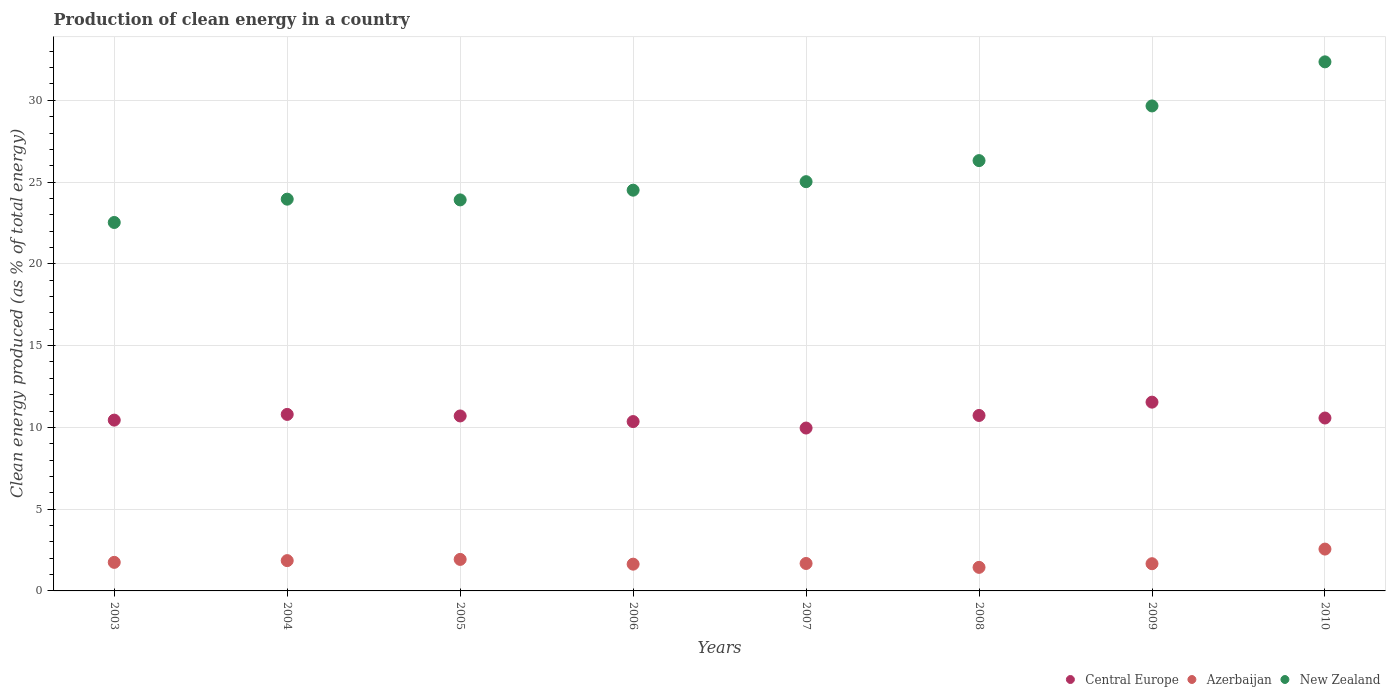How many different coloured dotlines are there?
Give a very brief answer. 3. What is the percentage of clean energy produced in New Zealand in 2007?
Provide a short and direct response. 25.03. Across all years, what is the maximum percentage of clean energy produced in New Zealand?
Keep it short and to the point. 32.35. Across all years, what is the minimum percentage of clean energy produced in Azerbaijan?
Offer a very short reply. 1.44. In which year was the percentage of clean energy produced in New Zealand minimum?
Your answer should be compact. 2003. What is the total percentage of clean energy produced in New Zealand in the graph?
Your answer should be very brief. 208.26. What is the difference between the percentage of clean energy produced in New Zealand in 2006 and that in 2010?
Make the answer very short. -7.85. What is the difference between the percentage of clean energy produced in New Zealand in 2006 and the percentage of clean energy produced in Central Europe in 2007?
Offer a very short reply. 14.55. What is the average percentage of clean energy produced in New Zealand per year?
Give a very brief answer. 26.03. In the year 2004, what is the difference between the percentage of clean energy produced in Azerbaijan and percentage of clean energy produced in Central Europe?
Ensure brevity in your answer.  -8.94. What is the ratio of the percentage of clean energy produced in Central Europe in 2003 to that in 2006?
Ensure brevity in your answer.  1.01. Is the percentage of clean energy produced in New Zealand in 2004 less than that in 2006?
Your answer should be very brief. Yes. Is the difference between the percentage of clean energy produced in Azerbaijan in 2003 and 2007 greater than the difference between the percentage of clean energy produced in Central Europe in 2003 and 2007?
Offer a terse response. No. What is the difference between the highest and the second highest percentage of clean energy produced in New Zealand?
Make the answer very short. 2.7. What is the difference between the highest and the lowest percentage of clean energy produced in Azerbaijan?
Your answer should be compact. 1.12. In how many years, is the percentage of clean energy produced in New Zealand greater than the average percentage of clean energy produced in New Zealand taken over all years?
Offer a terse response. 3. Is the sum of the percentage of clean energy produced in Azerbaijan in 2006 and 2008 greater than the maximum percentage of clean energy produced in New Zealand across all years?
Ensure brevity in your answer.  No. Is the percentage of clean energy produced in New Zealand strictly greater than the percentage of clean energy produced in Azerbaijan over the years?
Your answer should be compact. Yes. How many dotlines are there?
Keep it short and to the point. 3. How many years are there in the graph?
Make the answer very short. 8. What is the difference between two consecutive major ticks on the Y-axis?
Offer a very short reply. 5. Are the values on the major ticks of Y-axis written in scientific E-notation?
Your response must be concise. No. Does the graph contain any zero values?
Provide a short and direct response. No. What is the title of the graph?
Your answer should be very brief. Production of clean energy in a country. Does "North America" appear as one of the legend labels in the graph?
Your answer should be compact. No. What is the label or title of the Y-axis?
Keep it short and to the point. Clean energy produced (as % of total energy). What is the Clean energy produced (as % of total energy) in Central Europe in 2003?
Keep it short and to the point. 10.45. What is the Clean energy produced (as % of total energy) in Azerbaijan in 2003?
Your answer should be compact. 1.75. What is the Clean energy produced (as % of total energy) in New Zealand in 2003?
Give a very brief answer. 22.53. What is the Clean energy produced (as % of total energy) in Central Europe in 2004?
Your answer should be compact. 10.79. What is the Clean energy produced (as % of total energy) in Azerbaijan in 2004?
Offer a terse response. 1.85. What is the Clean energy produced (as % of total energy) in New Zealand in 2004?
Offer a very short reply. 23.96. What is the Clean energy produced (as % of total energy) in Central Europe in 2005?
Provide a short and direct response. 10.7. What is the Clean energy produced (as % of total energy) of Azerbaijan in 2005?
Offer a very short reply. 1.93. What is the Clean energy produced (as % of total energy) of New Zealand in 2005?
Your response must be concise. 23.91. What is the Clean energy produced (as % of total energy) of Central Europe in 2006?
Make the answer very short. 10.36. What is the Clean energy produced (as % of total energy) of Azerbaijan in 2006?
Give a very brief answer. 1.64. What is the Clean energy produced (as % of total energy) of New Zealand in 2006?
Give a very brief answer. 24.51. What is the Clean energy produced (as % of total energy) of Central Europe in 2007?
Your response must be concise. 9.96. What is the Clean energy produced (as % of total energy) in Azerbaijan in 2007?
Provide a short and direct response. 1.68. What is the Clean energy produced (as % of total energy) of New Zealand in 2007?
Keep it short and to the point. 25.03. What is the Clean energy produced (as % of total energy) of Central Europe in 2008?
Offer a very short reply. 10.73. What is the Clean energy produced (as % of total energy) in Azerbaijan in 2008?
Give a very brief answer. 1.44. What is the Clean energy produced (as % of total energy) in New Zealand in 2008?
Your answer should be very brief. 26.31. What is the Clean energy produced (as % of total energy) of Central Europe in 2009?
Give a very brief answer. 11.54. What is the Clean energy produced (as % of total energy) in Azerbaijan in 2009?
Keep it short and to the point. 1.66. What is the Clean energy produced (as % of total energy) of New Zealand in 2009?
Give a very brief answer. 29.66. What is the Clean energy produced (as % of total energy) of Central Europe in 2010?
Keep it short and to the point. 10.57. What is the Clean energy produced (as % of total energy) in Azerbaijan in 2010?
Give a very brief answer. 2.56. What is the Clean energy produced (as % of total energy) in New Zealand in 2010?
Give a very brief answer. 32.35. Across all years, what is the maximum Clean energy produced (as % of total energy) of Central Europe?
Your response must be concise. 11.54. Across all years, what is the maximum Clean energy produced (as % of total energy) of Azerbaijan?
Your response must be concise. 2.56. Across all years, what is the maximum Clean energy produced (as % of total energy) of New Zealand?
Offer a very short reply. 32.35. Across all years, what is the minimum Clean energy produced (as % of total energy) in Central Europe?
Offer a terse response. 9.96. Across all years, what is the minimum Clean energy produced (as % of total energy) in Azerbaijan?
Your response must be concise. 1.44. Across all years, what is the minimum Clean energy produced (as % of total energy) of New Zealand?
Provide a short and direct response. 22.53. What is the total Clean energy produced (as % of total energy) in Central Europe in the graph?
Provide a short and direct response. 85.1. What is the total Clean energy produced (as % of total energy) of Azerbaijan in the graph?
Your answer should be very brief. 14.51. What is the total Clean energy produced (as % of total energy) in New Zealand in the graph?
Your response must be concise. 208.26. What is the difference between the Clean energy produced (as % of total energy) of Central Europe in 2003 and that in 2004?
Keep it short and to the point. -0.35. What is the difference between the Clean energy produced (as % of total energy) in Azerbaijan in 2003 and that in 2004?
Your answer should be compact. -0.11. What is the difference between the Clean energy produced (as % of total energy) in New Zealand in 2003 and that in 2004?
Your answer should be very brief. -1.43. What is the difference between the Clean energy produced (as % of total energy) of Central Europe in 2003 and that in 2005?
Make the answer very short. -0.25. What is the difference between the Clean energy produced (as % of total energy) in Azerbaijan in 2003 and that in 2005?
Make the answer very short. -0.18. What is the difference between the Clean energy produced (as % of total energy) in New Zealand in 2003 and that in 2005?
Offer a very short reply. -1.38. What is the difference between the Clean energy produced (as % of total energy) in Central Europe in 2003 and that in 2006?
Your response must be concise. 0.09. What is the difference between the Clean energy produced (as % of total energy) in Azerbaijan in 2003 and that in 2006?
Give a very brief answer. 0.11. What is the difference between the Clean energy produced (as % of total energy) of New Zealand in 2003 and that in 2006?
Your answer should be compact. -1.98. What is the difference between the Clean energy produced (as % of total energy) of Central Europe in 2003 and that in 2007?
Offer a very short reply. 0.48. What is the difference between the Clean energy produced (as % of total energy) in Azerbaijan in 2003 and that in 2007?
Keep it short and to the point. 0.07. What is the difference between the Clean energy produced (as % of total energy) of New Zealand in 2003 and that in 2007?
Give a very brief answer. -2.5. What is the difference between the Clean energy produced (as % of total energy) of Central Europe in 2003 and that in 2008?
Keep it short and to the point. -0.28. What is the difference between the Clean energy produced (as % of total energy) in Azerbaijan in 2003 and that in 2008?
Provide a short and direct response. 0.31. What is the difference between the Clean energy produced (as % of total energy) in New Zealand in 2003 and that in 2008?
Give a very brief answer. -3.78. What is the difference between the Clean energy produced (as % of total energy) in Central Europe in 2003 and that in 2009?
Offer a terse response. -1.1. What is the difference between the Clean energy produced (as % of total energy) of Azerbaijan in 2003 and that in 2009?
Provide a short and direct response. 0.08. What is the difference between the Clean energy produced (as % of total energy) of New Zealand in 2003 and that in 2009?
Provide a succinct answer. -7.13. What is the difference between the Clean energy produced (as % of total energy) of Central Europe in 2003 and that in 2010?
Your answer should be very brief. -0.13. What is the difference between the Clean energy produced (as % of total energy) in Azerbaijan in 2003 and that in 2010?
Your answer should be very brief. -0.81. What is the difference between the Clean energy produced (as % of total energy) of New Zealand in 2003 and that in 2010?
Your answer should be compact. -9.82. What is the difference between the Clean energy produced (as % of total energy) of Central Europe in 2004 and that in 2005?
Provide a short and direct response. 0.09. What is the difference between the Clean energy produced (as % of total energy) of Azerbaijan in 2004 and that in 2005?
Keep it short and to the point. -0.07. What is the difference between the Clean energy produced (as % of total energy) in New Zealand in 2004 and that in 2005?
Make the answer very short. 0.04. What is the difference between the Clean energy produced (as % of total energy) in Central Europe in 2004 and that in 2006?
Offer a terse response. 0.44. What is the difference between the Clean energy produced (as % of total energy) of Azerbaijan in 2004 and that in 2006?
Offer a very short reply. 0.22. What is the difference between the Clean energy produced (as % of total energy) of New Zealand in 2004 and that in 2006?
Provide a short and direct response. -0.55. What is the difference between the Clean energy produced (as % of total energy) in Central Europe in 2004 and that in 2007?
Your answer should be very brief. 0.83. What is the difference between the Clean energy produced (as % of total energy) in Azerbaijan in 2004 and that in 2007?
Keep it short and to the point. 0.17. What is the difference between the Clean energy produced (as % of total energy) of New Zealand in 2004 and that in 2007?
Ensure brevity in your answer.  -1.07. What is the difference between the Clean energy produced (as % of total energy) in Central Europe in 2004 and that in 2008?
Provide a succinct answer. 0.06. What is the difference between the Clean energy produced (as % of total energy) of Azerbaijan in 2004 and that in 2008?
Your answer should be compact. 0.41. What is the difference between the Clean energy produced (as % of total energy) of New Zealand in 2004 and that in 2008?
Ensure brevity in your answer.  -2.36. What is the difference between the Clean energy produced (as % of total energy) of Central Europe in 2004 and that in 2009?
Provide a short and direct response. -0.75. What is the difference between the Clean energy produced (as % of total energy) in Azerbaijan in 2004 and that in 2009?
Your response must be concise. 0.19. What is the difference between the Clean energy produced (as % of total energy) of New Zealand in 2004 and that in 2009?
Make the answer very short. -5.7. What is the difference between the Clean energy produced (as % of total energy) of Central Europe in 2004 and that in 2010?
Offer a terse response. 0.22. What is the difference between the Clean energy produced (as % of total energy) in Azerbaijan in 2004 and that in 2010?
Ensure brevity in your answer.  -0.71. What is the difference between the Clean energy produced (as % of total energy) in New Zealand in 2004 and that in 2010?
Provide a succinct answer. -8.4. What is the difference between the Clean energy produced (as % of total energy) of Central Europe in 2005 and that in 2006?
Give a very brief answer. 0.34. What is the difference between the Clean energy produced (as % of total energy) in Azerbaijan in 2005 and that in 2006?
Provide a short and direct response. 0.29. What is the difference between the Clean energy produced (as % of total energy) of New Zealand in 2005 and that in 2006?
Offer a terse response. -0.59. What is the difference between the Clean energy produced (as % of total energy) in Central Europe in 2005 and that in 2007?
Your answer should be compact. 0.74. What is the difference between the Clean energy produced (as % of total energy) in Azerbaijan in 2005 and that in 2007?
Provide a succinct answer. 0.25. What is the difference between the Clean energy produced (as % of total energy) in New Zealand in 2005 and that in 2007?
Offer a terse response. -1.11. What is the difference between the Clean energy produced (as % of total energy) of Central Europe in 2005 and that in 2008?
Offer a very short reply. -0.03. What is the difference between the Clean energy produced (as % of total energy) of Azerbaijan in 2005 and that in 2008?
Your answer should be compact. 0.49. What is the difference between the Clean energy produced (as % of total energy) of New Zealand in 2005 and that in 2008?
Your answer should be very brief. -2.4. What is the difference between the Clean energy produced (as % of total energy) of Central Europe in 2005 and that in 2009?
Ensure brevity in your answer.  -0.84. What is the difference between the Clean energy produced (as % of total energy) of Azerbaijan in 2005 and that in 2009?
Keep it short and to the point. 0.26. What is the difference between the Clean energy produced (as % of total energy) in New Zealand in 2005 and that in 2009?
Provide a short and direct response. -5.75. What is the difference between the Clean energy produced (as % of total energy) in Central Europe in 2005 and that in 2010?
Offer a terse response. 0.13. What is the difference between the Clean energy produced (as % of total energy) in Azerbaijan in 2005 and that in 2010?
Your answer should be very brief. -0.63. What is the difference between the Clean energy produced (as % of total energy) in New Zealand in 2005 and that in 2010?
Your response must be concise. -8.44. What is the difference between the Clean energy produced (as % of total energy) in Central Europe in 2006 and that in 2007?
Offer a terse response. 0.4. What is the difference between the Clean energy produced (as % of total energy) in Azerbaijan in 2006 and that in 2007?
Make the answer very short. -0.04. What is the difference between the Clean energy produced (as % of total energy) in New Zealand in 2006 and that in 2007?
Provide a succinct answer. -0.52. What is the difference between the Clean energy produced (as % of total energy) of Central Europe in 2006 and that in 2008?
Offer a terse response. -0.37. What is the difference between the Clean energy produced (as % of total energy) in Azerbaijan in 2006 and that in 2008?
Offer a terse response. 0.2. What is the difference between the Clean energy produced (as % of total energy) in New Zealand in 2006 and that in 2008?
Offer a terse response. -1.81. What is the difference between the Clean energy produced (as % of total energy) in Central Europe in 2006 and that in 2009?
Provide a succinct answer. -1.19. What is the difference between the Clean energy produced (as % of total energy) of Azerbaijan in 2006 and that in 2009?
Offer a terse response. -0.03. What is the difference between the Clean energy produced (as % of total energy) in New Zealand in 2006 and that in 2009?
Provide a short and direct response. -5.15. What is the difference between the Clean energy produced (as % of total energy) of Central Europe in 2006 and that in 2010?
Keep it short and to the point. -0.22. What is the difference between the Clean energy produced (as % of total energy) in Azerbaijan in 2006 and that in 2010?
Keep it short and to the point. -0.92. What is the difference between the Clean energy produced (as % of total energy) of New Zealand in 2006 and that in 2010?
Provide a short and direct response. -7.85. What is the difference between the Clean energy produced (as % of total energy) in Central Europe in 2007 and that in 2008?
Provide a succinct answer. -0.77. What is the difference between the Clean energy produced (as % of total energy) of Azerbaijan in 2007 and that in 2008?
Provide a short and direct response. 0.24. What is the difference between the Clean energy produced (as % of total energy) in New Zealand in 2007 and that in 2008?
Your answer should be very brief. -1.29. What is the difference between the Clean energy produced (as % of total energy) of Central Europe in 2007 and that in 2009?
Provide a short and direct response. -1.58. What is the difference between the Clean energy produced (as % of total energy) in Azerbaijan in 2007 and that in 2009?
Your answer should be very brief. 0.01. What is the difference between the Clean energy produced (as % of total energy) in New Zealand in 2007 and that in 2009?
Keep it short and to the point. -4.63. What is the difference between the Clean energy produced (as % of total energy) in Central Europe in 2007 and that in 2010?
Keep it short and to the point. -0.61. What is the difference between the Clean energy produced (as % of total energy) of Azerbaijan in 2007 and that in 2010?
Offer a very short reply. -0.88. What is the difference between the Clean energy produced (as % of total energy) in New Zealand in 2007 and that in 2010?
Provide a succinct answer. -7.33. What is the difference between the Clean energy produced (as % of total energy) in Central Europe in 2008 and that in 2009?
Offer a terse response. -0.81. What is the difference between the Clean energy produced (as % of total energy) of Azerbaijan in 2008 and that in 2009?
Make the answer very short. -0.22. What is the difference between the Clean energy produced (as % of total energy) of New Zealand in 2008 and that in 2009?
Make the answer very short. -3.34. What is the difference between the Clean energy produced (as % of total energy) in Central Europe in 2008 and that in 2010?
Make the answer very short. 0.16. What is the difference between the Clean energy produced (as % of total energy) of Azerbaijan in 2008 and that in 2010?
Give a very brief answer. -1.12. What is the difference between the Clean energy produced (as % of total energy) in New Zealand in 2008 and that in 2010?
Make the answer very short. -6.04. What is the difference between the Clean energy produced (as % of total energy) of Azerbaijan in 2009 and that in 2010?
Ensure brevity in your answer.  -0.89. What is the difference between the Clean energy produced (as % of total energy) of New Zealand in 2009 and that in 2010?
Your answer should be very brief. -2.7. What is the difference between the Clean energy produced (as % of total energy) of Central Europe in 2003 and the Clean energy produced (as % of total energy) of Azerbaijan in 2004?
Give a very brief answer. 8.59. What is the difference between the Clean energy produced (as % of total energy) in Central Europe in 2003 and the Clean energy produced (as % of total energy) in New Zealand in 2004?
Your response must be concise. -13.51. What is the difference between the Clean energy produced (as % of total energy) in Azerbaijan in 2003 and the Clean energy produced (as % of total energy) in New Zealand in 2004?
Your answer should be very brief. -22.21. What is the difference between the Clean energy produced (as % of total energy) of Central Europe in 2003 and the Clean energy produced (as % of total energy) of Azerbaijan in 2005?
Your answer should be very brief. 8.52. What is the difference between the Clean energy produced (as % of total energy) of Central Europe in 2003 and the Clean energy produced (as % of total energy) of New Zealand in 2005?
Make the answer very short. -13.47. What is the difference between the Clean energy produced (as % of total energy) in Azerbaijan in 2003 and the Clean energy produced (as % of total energy) in New Zealand in 2005?
Provide a succinct answer. -22.17. What is the difference between the Clean energy produced (as % of total energy) in Central Europe in 2003 and the Clean energy produced (as % of total energy) in Azerbaijan in 2006?
Give a very brief answer. 8.81. What is the difference between the Clean energy produced (as % of total energy) of Central Europe in 2003 and the Clean energy produced (as % of total energy) of New Zealand in 2006?
Your response must be concise. -14.06. What is the difference between the Clean energy produced (as % of total energy) of Azerbaijan in 2003 and the Clean energy produced (as % of total energy) of New Zealand in 2006?
Provide a succinct answer. -22.76. What is the difference between the Clean energy produced (as % of total energy) in Central Europe in 2003 and the Clean energy produced (as % of total energy) in Azerbaijan in 2007?
Provide a short and direct response. 8.77. What is the difference between the Clean energy produced (as % of total energy) of Central Europe in 2003 and the Clean energy produced (as % of total energy) of New Zealand in 2007?
Give a very brief answer. -14.58. What is the difference between the Clean energy produced (as % of total energy) in Azerbaijan in 2003 and the Clean energy produced (as % of total energy) in New Zealand in 2007?
Your answer should be compact. -23.28. What is the difference between the Clean energy produced (as % of total energy) of Central Europe in 2003 and the Clean energy produced (as % of total energy) of Azerbaijan in 2008?
Make the answer very short. 9. What is the difference between the Clean energy produced (as % of total energy) in Central Europe in 2003 and the Clean energy produced (as % of total energy) in New Zealand in 2008?
Offer a very short reply. -15.87. What is the difference between the Clean energy produced (as % of total energy) of Azerbaijan in 2003 and the Clean energy produced (as % of total energy) of New Zealand in 2008?
Your answer should be compact. -24.57. What is the difference between the Clean energy produced (as % of total energy) in Central Europe in 2003 and the Clean energy produced (as % of total energy) in Azerbaijan in 2009?
Offer a terse response. 8.78. What is the difference between the Clean energy produced (as % of total energy) of Central Europe in 2003 and the Clean energy produced (as % of total energy) of New Zealand in 2009?
Give a very brief answer. -19.21. What is the difference between the Clean energy produced (as % of total energy) of Azerbaijan in 2003 and the Clean energy produced (as % of total energy) of New Zealand in 2009?
Your answer should be compact. -27.91. What is the difference between the Clean energy produced (as % of total energy) of Central Europe in 2003 and the Clean energy produced (as % of total energy) of Azerbaijan in 2010?
Keep it short and to the point. 7.89. What is the difference between the Clean energy produced (as % of total energy) in Central Europe in 2003 and the Clean energy produced (as % of total energy) in New Zealand in 2010?
Ensure brevity in your answer.  -21.91. What is the difference between the Clean energy produced (as % of total energy) in Azerbaijan in 2003 and the Clean energy produced (as % of total energy) in New Zealand in 2010?
Give a very brief answer. -30.61. What is the difference between the Clean energy produced (as % of total energy) in Central Europe in 2004 and the Clean energy produced (as % of total energy) in Azerbaijan in 2005?
Make the answer very short. 8.87. What is the difference between the Clean energy produced (as % of total energy) of Central Europe in 2004 and the Clean energy produced (as % of total energy) of New Zealand in 2005?
Give a very brief answer. -13.12. What is the difference between the Clean energy produced (as % of total energy) in Azerbaijan in 2004 and the Clean energy produced (as % of total energy) in New Zealand in 2005?
Your response must be concise. -22.06. What is the difference between the Clean energy produced (as % of total energy) of Central Europe in 2004 and the Clean energy produced (as % of total energy) of Azerbaijan in 2006?
Your answer should be very brief. 9.16. What is the difference between the Clean energy produced (as % of total energy) of Central Europe in 2004 and the Clean energy produced (as % of total energy) of New Zealand in 2006?
Your answer should be very brief. -13.71. What is the difference between the Clean energy produced (as % of total energy) in Azerbaijan in 2004 and the Clean energy produced (as % of total energy) in New Zealand in 2006?
Offer a very short reply. -22.65. What is the difference between the Clean energy produced (as % of total energy) in Central Europe in 2004 and the Clean energy produced (as % of total energy) in Azerbaijan in 2007?
Your answer should be very brief. 9.12. What is the difference between the Clean energy produced (as % of total energy) in Central Europe in 2004 and the Clean energy produced (as % of total energy) in New Zealand in 2007?
Give a very brief answer. -14.23. What is the difference between the Clean energy produced (as % of total energy) in Azerbaijan in 2004 and the Clean energy produced (as % of total energy) in New Zealand in 2007?
Your answer should be very brief. -23.17. What is the difference between the Clean energy produced (as % of total energy) in Central Europe in 2004 and the Clean energy produced (as % of total energy) in Azerbaijan in 2008?
Provide a short and direct response. 9.35. What is the difference between the Clean energy produced (as % of total energy) in Central Europe in 2004 and the Clean energy produced (as % of total energy) in New Zealand in 2008?
Give a very brief answer. -15.52. What is the difference between the Clean energy produced (as % of total energy) of Azerbaijan in 2004 and the Clean energy produced (as % of total energy) of New Zealand in 2008?
Your response must be concise. -24.46. What is the difference between the Clean energy produced (as % of total energy) in Central Europe in 2004 and the Clean energy produced (as % of total energy) in Azerbaijan in 2009?
Ensure brevity in your answer.  9.13. What is the difference between the Clean energy produced (as % of total energy) of Central Europe in 2004 and the Clean energy produced (as % of total energy) of New Zealand in 2009?
Offer a very short reply. -18.86. What is the difference between the Clean energy produced (as % of total energy) in Azerbaijan in 2004 and the Clean energy produced (as % of total energy) in New Zealand in 2009?
Offer a terse response. -27.8. What is the difference between the Clean energy produced (as % of total energy) in Central Europe in 2004 and the Clean energy produced (as % of total energy) in Azerbaijan in 2010?
Your response must be concise. 8.24. What is the difference between the Clean energy produced (as % of total energy) of Central Europe in 2004 and the Clean energy produced (as % of total energy) of New Zealand in 2010?
Make the answer very short. -21.56. What is the difference between the Clean energy produced (as % of total energy) in Azerbaijan in 2004 and the Clean energy produced (as % of total energy) in New Zealand in 2010?
Give a very brief answer. -30.5. What is the difference between the Clean energy produced (as % of total energy) in Central Europe in 2005 and the Clean energy produced (as % of total energy) in Azerbaijan in 2006?
Provide a succinct answer. 9.06. What is the difference between the Clean energy produced (as % of total energy) of Central Europe in 2005 and the Clean energy produced (as % of total energy) of New Zealand in 2006?
Offer a very short reply. -13.81. What is the difference between the Clean energy produced (as % of total energy) of Azerbaijan in 2005 and the Clean energy produced (as % of total energy) of New Zealand in 2006?
Your response must be concise. -22.58. What is the difference between the Clean energy produced (as % of total energy) in Central Europe in 2005 and the Clean energy produced (as % of total energy) in Azerbaijan in 2007?
Provide a succinct answer. 9.02. What is the difference between the Clean energy produced (as % of total energy) in Central Europe in 2005 and the Clean energy produced (as % of total energy) in New Zealand in 2007?
Your answer should be compact. -14.33. What is the difference between the Clean energy produced (as % of total energy) of Azerbaijan in 2005 and the Clean energy produced (as % of total energy) of New Zealand in 2007?
Your answer should be very brief. -23.1. What is the difference between the Clean energy produced (as % of total energy) in Central Europe in 2005 and the Clean energy produced (as % of total energy) in Azerbaijan in 2008?
Provide a succinct answer. 9.26. What is the difference between the Clean energy produced (as % of total energy) in Central Europe in 2005 and the Clean energy produced (as % of total energy) in New Zealand in 2008?
Keep it short and to the point. -15.61. What is the difference between the Clean energy produced (as % of total energy) of Azerbaijan in 2005 and the Clean energy produced (as % of total energy) of New Zealand in 2008?
Offer a terse response. -24.39. What is the difference between the Clean energy produced (as % of total energy) of Central Europe in 2005 and the Clean energy produced (as % of total energy) of Azerbaijan in 2009?
Provide a succinct answer. 9.04. What is the difference between the Clean energy produced (as % of total energy) in Central Europe in 2005 and the Clean energy produced (as % of total energy) in New Zealand in 2009?
Keep it short and to the point. -18.96. What is the difference between the Clean energy produced (as % of total energy) of Azerbaijan in 2005 and the Clean energy produced (as % of total energy) of New Zealand in 2009?
Offer a very short reply. -27.73. What is the difference between the Clean energy produced (as % of total energy) of Central Europe in 2005 and the Clean energy produced (as % of total energy) of Azerbaijan in 2010?
Provide a short and direct response. 8.14. What is the difference between the Clean energy produced (as % of total energy) of Central Europe in 2005 and the Clean energy produced (as % of total energy) of New Zealand in 2010?
Your answer should be compact. -21.65. What is the difference between the Clean energy produced (as % of total energy) of Azerbaijan in 2005 and the Clean energy produced (as % of total energy) of New Zealand in 2010?
Offer a terse response. -30.43. What is the difference between the Clean energy produced (as % of total energy) of Central Europe in 2006 and the Clean energy produced (as % of total energy) of Azerbaijan in 2007?
Your answer should be very brief. 8.68. What is the difference between the Clean energy produced (as % of total energy) in Central Europe in 2006 and the Clean energy produced (as % of total energy) in New Zealand in 2007?
Your answer should be compact. -14.67. What is the difference between the Clean energy produced (as % of total energy) in Azerbaijan in 2006 and the Clean energy produced (as % of total energy) in New Zealand in 2007?
Your response must be concise. -23.39. What is the difference between the Clean energy produced (as % of total energy) in Central Europe in 2006 and the Clean energy produced (as % of total energy) in Azerbaijan in 2008?
Offer a very short reply. 8.92. What is the difference between the Clean energy produced (as % of total energy) of Central Europe in 2006 and the Clean energy produced (as % of total energy) of New Zealand in 2008?
Make the answer very short. -15.96. What is the difference between the Clean energy produced (as % of total energy) in Azerbaijan in 2006 and the Clean energy produced (as % of total energy) in New Zealand in 2008?
Keep it short and to the point. -24.68. What is the difference between the Clean energy produced (as % of total energy) in Central Europe in 2006 and the Clean energy produced (as % of total energy) in Azerbaijan in 2009?
Your answer should be compact. 8.69. What is the difference between the Clean energy produced (as % of total energy) of Central Europe in 2006 and the Clean energy produced (as % of total energy) of New Zealand in 2009?
Ensure brevity in your answer.  -19.3. What is the difference between the Clean energy produced (as % of total energy) in Azerbaijan in 2006 and the Clean energy produced (as % of total energy) in New Zealand in 2009?
Offer a very short reply. -28.02. What is the difference between the Clean energy produced (as % of total energy) of Central Europe in 2006 and the Clean energy produced (as % of total energy) of Azerbaijan in 2010?
Provide a short and direct response. 7.8. What is the difference between the Clean energy produced (as % of total energy) in Central Europe in 2006 and the Clean energy produced (as % of total energy) in New Zealand in 2010?
Offer a very short reply. -22. What is the difference between the Clean energy produced (as % of total energy) of Azerbaijan in 2006 and the Clean energy produced (as % of total energy) of New Zealand in 2010?
Keep it short and to the point. -30.72. What is the difference between the Clean energy produced (as % of total energy) in Central Europe in 2007 and the Clean energy produced (as % of total energy) in Azerbaijan in 2008?
Give a very brief answer. 8.52. What is the difference between the Clean energy produced (as % of total energy) in Central Europe in 2007 and the Clean energy produced (as % of total energy) in New Zealand in 2008?
Your response must be concise. -16.35. What is the difference between the Clean energy produced (as % of total energy) in Azerbaijan in 2007 and the Clean energy produced (as % of total energy) in New Zealand in 2008?
Your answer should be compact. -24.64. What is the difference between the Clean energy produced (as % of total energy) of Central Europe in 2007 and the Clean energy produced (as % of total energy) of Azerbaijan in 2009?
Offer a terse response. 8.3. What is the difference between the Clean energy produced (as % of total energy) in Central Europe in 2007 and the Clean energy produced (as % of total energy) in New Zealand in 2009?
Your answer should be very brief. -19.7. What is the difference between the Clean energy produced (as % of total energy) in Azerbaijan in 2007 and the Clean energy produced (as % of total energy) in New Zealand in 2009?
Keep it short and to the point. -27.98. What is the difference between the Clean energy produced (as % of total energy) in Central Europe in 2007 and the Clean energy produced (as % of total energy) in Azerbaijan in 2010?
Offer a terse response. 7.4. What is the difference between the Clean energy produced (as % of total energy) in Central Europe in 2007 and the Clean energy produced (as % of total energy) in New Zealand in 2010?
Provide a short and direct response. -22.39. What is the difference between the Clean energy produced (as % of total energy) of Azerbaijan in 2007 and the Clean energy produced (as % of total energy) of New Zealand in 2010?
Your answer should be compact. -30.68. What is the difference between the Clean energy produced (as % of total energy) of Central Europe in 2008 and the Clean energy produced (as % of total energy) of Azerbaijan in 2009?
Your answer should be very brief. 9.07. What is the difference between the Clean energy produced (as % of total energy) of Central Europe in 2008 and the Clean energy produced (as % of total energy) of New Zealand in 2009?
Your answer should be very brief. -18.93. What is the difference between the Clean energy produced (as % of total energy) in Azerbaijan in 2008 and the Clean energy produced (as % of total energy) in New Zealand in 2009?
Ensure brevity in your answer.  -28.22. What is the difference between the Clean energy produced (as % of total energy) of Central Europe in 2008 and the Clean energy produced (as % of total energy) of Azerbaijan in 2010?
Give a very brief answer. 8.17. What is the difference between the Clean energy produced (as % of total energy) in Central Europe in 2008 and the Clean energy produced (as % of total energy) in New Zealand in 2010?
Ensure brevity in your answer.  -21.62. What is the difference between the Clean energy produced (as % of total energy) in Azerbaijan in 2008 and the Clean energy produced (as % of total energy) in New Zealand in 2010?
Your answer should be very brief. -30.91. What is the difference between the Clean energy produced (as % of total energy) in Central Europe in 2009 and the Clean energy produced (as % of total energy) in Azerbaijan in 2010?
Your response must be concise. 8.98. What is the difference between the Clean energy produced (as % of total energy) of Central Europe in 2009 and the Clean energy produced (as % of total energy) of New Zealand in 2010?
Your response must be concise. -20.81. What is the difference between the Clean energy produced (as % of total energy) of Azerbaijan in 2009 and the Clean energy produced (as % of total energy) of New Zealand in 2010?
Provide a succinct answer. -30.69. What is the average Clean energy produced (as % of total energy) in Central Europe per year?
Make the answer very short. 10.64. What is the average Clean energy produced (as % of total energy) of Azerbaijan per year?
Keep it short and to the point. 1.81. What is the average Clean energy produced (as % of total energy) in New Zealand per year?
Provide a short and direct response. 26.03. In the year 2003, what is the difference between the Clean energy produced (as % of total energy) of Central Europe and Clean energy produced (as % of total energy) of Azerbaijan?
Keep it short and to the point. 8.7. In the year 2003, what is the difference between the Clean energy produced (as % of total energy) of Central Europe and Clean energy produced (as % of total energy) of New Zealand?
Provide a succinct answer. -12.09. In the year 2003, what is the difference between the Clean energy produced (as % of total energy) of Azerbaijan and Clean energy produced (as % of total energy) of New Zealand?
Ensure brevity in your answer.  -20.78. In the year 2004, what is the difference between the Clean energy produced (as % of total energy) of Central Europe and Clean energy produced (as % of total energy) of Azerbaijan?
Make the answer very short. 8.94. In the year 2004, what is the difference between the Clean energy produced (as % of total energy) of Central Europe and Clean energy produced (as % of total energy) of New Zealand?
Provide a short and direct response. -13.16. In the year 2004, what is the difference between the Clean energy produced (as % of total energy) in Azerbaijan and Clean energy produced (as % of total energy) in New Zealand?
Provide a short and direct response. -22.1. In the year 2005, what is the difference between the Clean energy produced (as % of total energy) in Central Europe and Clean energy produced (as % of total energy) in Azerbaijan?
Provide a short and direct response. 8.77. In the year 2005, what is the difference between the Clean energy produced (as % of total energy) of Central Europe and Clean energy produced (as % of total energy) of New Zealand?
Keep it short and to the point. -13.21. In the year 2005, what is the difference between the Clean energy produced (as % of total energy) of Azerbaijan and Clean energy produced (as % of total energy) of New Zealand?
Your answer should be compact. -21.98. In the year 2006, what is the difference between the Clean energy produced (as % of total energy) in Central Europe and Clean energy produced (as % of total energy) in Azerbaijan?
Your answer should be very brief. 8.72. In the year 2006, what is the difference between the Clean energy produced (as % of total energy) of Central Europe and Clean energy produced (as % of total energy) of New Zealand?
Provide a short and direct response. -14.15. In the year 2006, what is the difference between the Clean energy produced (as % of total energy) of Azerbaijan and Clean energy produced (as % of total energy) of New Zealand?
Make the answer very short. -22.87. In the year 2007, what is the difference between the Clean energy produced (as % of total energy) in Central Europe and Clean energy produced (as % of total energy) in Azerbaijan?
Give a very brief answer. 8.28. In the year 2007, what is the difference between the Clean energy produced (as % of total energy) of Central Europe and Clean energy produced (as % of total energy) of New Zealand?
Your answer should be compact. -15.07. In the year 2007, what is the difference between the Clean energy produced (as % of total energy) in Azerbaijan and Clean energy produced (as % of total energy) in New Zealand?
Offer a terse response. -23.35. In the year 2008, what is the difference between the Clean energy produced (as % of total energy) of Central Europe and Clean energy produced (as % of total energy) of Azerbaijan?
Your answer should be very brief. 9.29. In the year 2008, what is the difference between the Clean energy produced (as % of total energy) of Central Europe and Clean energy produced (as % of total energy) of New Zealand?
Keep it short and to the point. -15.58. In the year 2008, what is the difference between the Clean energy produced (as % of total energy) in Azerbaijan and Clean energy produced (as % of total energy) in New Zealand?
Provide a succinct answer. -24.87. In the year 2009, what is the difference between the Clean energy produced (as % of total energy) of Central Europe and Clean energy produced (as % of total energy) of Azerbaijan?
Your answer should be compact. 9.88. In the year 2009, what is the difference between the Clean energy produced (as % of total energy) of Central Europe and Clean energy produced (as % of total energy) of New Zealand?
Keep it short and to the point. -18.11. In the year 2009, what is the difference between the Clean energy produced (as % of total energy) in Azerbaijan and Clean energy produced (as % of total energy) in New Zealand?
Offer a terse response. -27.99. In the year 2010, what is the difference between the Clean energy produced (as % of total energy) in Central Europe and Clean energy produced (as % of total energy) in Azerbaijan?
Ensure brevity in your answer.  8.01. In the year 2010, what is the difference between the Clean energy produced (as % of total energy) of Central Europe and Clean energy produced (as % of total energy) of New Zealand?
Provide a short and direct response. -21.78. In the year 2010, what is the difference between the Clean energy produced (as % of total energy) of Azerbaijan and Clean energy produced (as % of total energy) of New Zealand?
Offer a very short reply. -29.79. What is the ratio of the Clean energy produced (as % of total energy) in Central Europe in 2003 to that in 2004?
Offer a terse response. 0.97. What is the ratio of the Clean energy produced (as % of total energy) in Azerbaijan in 2003 to that in 2004?
Give a very brief answer. 0.94. What is the ratio of the Clean energy produced (as % of total energy) of New Zealand in 2003 to that in 2004?
Your response must be concise. 0.94. What is the ratio of the Clean energy produced (as % of total energy) in Central Europe in 2003 to that in 2005?
Ensure brevity in your answer.  0.98. What is the ratio of the Clean energy produced (as % of total energy) in Azerbaijan in 2003 to that in 2005?
Keep it short and to the point. 0.91. What is the ratio of the Clean energy produced (as % of total energy) of New Zealand in 2003 to that in 2005?
Offer a terse response. 0.94. What is the ratio of the Clean energy produced (as % of total energy) of Central Europe in 2003 to that in 2006?
Provide a short and direct response. 1.01. What is the ratio of the Clean energy produced (as % of total energy) of Azerbaijan in 2003 to that in 2006?
Offer a very short reply. 1.07. What is the ratio of the Clean energy produced (as % of total energy) in New Zealand in 2003 to that in 2006?
Your answer should be compact. 0.92. What is the ratio of the Clean energy produced (as % of total energy) in Central Europe in 2003 to that in 2007?
Keep it short and to the point. 1.05. What is the ratio of the Clean energy produced (as % of total energy) in Azerbaijan in 2003 to that in 2007?
Your answer should be compact. 1.04. What is the ratio of the Clean energy produced (as % of total energy) in New Zealand in 2003 to that in 2007?
Your answer should be compact. 0.9. What is the ratio of the Clean energy produced (as % of total energy) of Central Europe in 2003 to that in 2008?
Your response must be concise. 0.97. What is the ratio of the Clean energy produced (as % of total energy) in Azerbaijan in 2003 to that in 2008?
Keep it short and to the point. 1.21. What is the ratio of the Clean energy produced (as % of total energy) of New Zealand in 2003 to that in 2008?
Provide a succinct answer. 0.86. What is the ratio of the Clean energy produced (as % of total energy) in Central Europe in 2003 to that in 2009?
Make the answer very short. 0.9. What is the ratio of the Clean energy produced (as % of total energy) in Azerbaijan in 2003 to that in 2009?
Your answer should be compact. 1.05. What is the ratio of the Clean energy produced (as % of total energy) of New Zealand in 2003 to that in 2009?
Make the answer very short. 0.76. What is the ratio of the Clean energy produced (as % of total energy) in Central Europe in 2003 to that in 2010?
Offer a terse response. 0.99. What is the ratio of the Clean energy produced (as % of total energy) of Azerbaijan in 2003 to that in 2010?
Keep it short and to the point. 0.68. What is the ratio of the Clean energy produced (as % of total energy) of New Zealand in 2003 to that in 2010?
Your response must be concise. 0.7. What is the ratio of the Clean energy produced (as % of total energy) of Central Europe in 2004 to that in 2005?
Give a very brief answer. 1.01. What is the ratio of the Clean energy produced (as % of total energy) in Azerbaijan in 2004 to that in 2005?
Your answer should be very brief. 0.96. What is the ratio of the Clean energy produced (as % of total energy) in Central Europe in 2004 to that in 2006?
Ensure brevity in your answer.  1.04. What is the ratio of the Clean energy produced (as % of total energy) in Azerbaijan in 2004 to that in 2006?
Keep it short and to the point. 1.13. What is the ratio of the Clean energy produced (as % of total energy) of New Zealand in 2004 to that in 2006?
Provide a short and direct response. 0.98. What is the ratio of the Clean energy produced (as % of total energy) of Central Europe in 2004 to that in 2007?
Give a very brief answer. 1.08. What is the ratio of the Clean energy produced (as % of total energy) in Azerbaijan in 2004 to that in 2007?
Ensure brevity in your answer.  1.1. What is the ratio of the Clean energy produced (as % of total energy) in New Zealand in 2004 to that in 2007?
Provide a succinct answer. 0.96. What is the ratio of the Clean energy produced (as % of total energy) of Azerbaijan in 2004 to that in 2008?
Give a very brief answer. 1.29. What is the ratio of the Clean energy produced (as % of total energy) of New Zealand in 2004 to that in 2008?
Your response must be concise. 0.91. What is the ratio of the Clean energy produced (as % of total energy) in Central Europe in 2004 to that in 2009?
Offer a very short reply. 0.94. What is the ratio of the Clean energy produced (as % of total energy) of Azerbaijan in 2004 to that in 2009?
Offer a very short reply. 1.11. What is the ratio of the Clean energy produced (as % of total energy) in New Zealand in 2004 to that in 2009?
Keep it short and to the point. 0.81. What is the ratio of the Clean energy produced (as % of total energy) in Central Europe in 2004 to that in 2010?
Make the answer very short. 1.02. What is the ratio of the Clean energy produced (as % of total energy) in Azerbaijan in 2004 to that in 2010?
Offer a very short reply. 0.72. What is the ratio of the Clean energy produced (as % of total energy) in New Zealand in 2004 to that in 2010?
Offer a terse response. 0.74. What is the ratio of the Clean energy produced (as % of total energy) in Central Europe in 2005 to that in 2006?
Offer a very short reply. 1.03. What is the ratio of the Clean energy produced (as % of total energy) of Azerbaijan in 2005 to that in 2006?
Keep it short and to the point. 1.18. What is the ratio of the Clean energy produced (as % of total energy) in New Zealand in 2005 to that in 2006?
Your answer should be compact. 0.98. What is the ratio of the Clean energy produced (as % of total energy) of Central Europe in 2005 to that in 2007?
Give a very brief answer. 1.07. What is the ratio of the Clean energy produced (as % of total energy) of Azerbaijan in 2005 to that in 2007?
Your answer should be very brief. 1.15. What is the ratio of the Clean energy produced (as % of total energy) of New Zealand in 2005 to that in 2007?
Provide a short and direct response. 0.96. What is the ratio of the Clean energy produced (as % of total energy) in Azerbaijan in 2005 to that in 2008?
Your answer should be compact. 1.34. What is the ratio of the Clean energy produced (as % of total energy) of New Zealand in 2005 to that in 2008?
Provide a short and direct response. 0.91. What is the ratio of the Clean energy produced (as % of total energy) of Central Europe in 2005 to that in 2009?
Make the answer very short. 0.93. What is the ratio of the Clean energy produced (as % of total energy) in Azerbaijan in 2005 to that in 2009?
Ensure brevity in your answer.  1.16. What is the ratio of the Clean energy produced (as % of total energy) in New Zealand in 2005 to that in 2009?
Give a very brief answer. 0.81. What is the ratio of the Clean energy produced (as % of total energy) of Central Europe in 2005 to that in 2010?
Provide a short and direct response. 1.01. What is the ratio of the Clean energy produced (as % of total energy) in Azerbaijan in 2005 to that in 2010?
Keep it short and to the point. 0.75. What is the ratio of the Clean energy produced (as % of total energy) in New Zealand in 2005 to that in 2010?
Your answer should be very brief. 0.74. What is the ratio of the Clean energy produced (as % of total energy) in Central Europe in 2006 to that in 2007?
Give a very brief answer. 1.04. What is the ratio of the Clean energy produced (as % of total energy) in New Zealand in 2006 to that in 2007?
Provide a succinct answer. 0.98. What is the ratio of the Clean energy produced (as % of total energy) in Central Europe in 2006 to that in 2008?
Give a very brief answer. 0.97. What is the ratio of the Clean energy produced (as % of total energy) of Azerbaijan in 2006 to that in 2008?
Your answer should be compact. 1.14. What is the ratio of the Clean energy produced (as % of total energy) in New Zealand in 2006 to that in 2008?
Make the answer very short. 0.93. What is the ratio of the Clean energy produced (as % of total energy) of Central Europe in 2006 to that in 2009?
Your response must be concise. 0.9. What is the ratio of the Clean energy produced (as % of total energy) of Azerbaijan in 2006 to that in 2009?
Ensure brevity in your answer.  0.98. What is the ratio of the Clean energy produced (as % of total energy) in New Zealand in 2006 to that in 2009?
Offer a terse response. 0.83. What is the ratio of the Clean energy produced (as % of total energy) of Central Europe in 2006 to that in 2010?
Your answer should be compact. 0.98. What is the ratio of the Clean energy produced (as % of total energy) in Azerbaijan in 2006 to that in 2010?
Provide a succinct answer. 0.64. What is the ratio of the Clean energy produced (as % of total energy) of New Zealand in 2006 to that in 2010?
Provide a short and direct response. 0.76. What is the ratio of the Clean energy produced (as % of total energy) in Central Europe in 2007 to that in 2008?
Your response must be concise. 0.93. What is the ratio of the Clean energy produced (as % of total energy) of Azerbaijan in 2007 to that in 2008?
Provide a short and direct response. 1.17. What is the ratio of the Clean energy produced (as % of total energy) of New Zealand in 2007 to that in 2008?
Your answer should be very brief. 0.95. What is the ratio of the Clean energy produced (as % of total energy) of Central Europe in 2007 to that in 2009?
Offer a terse response. 0.86. What is the ratio of the Clean energy produced (as % of total energy) of Azerbaijan in 2007 to that in 2009?
Give a very brief answer. 1.01. What is the ratio of the Clean energy produced (as % of total energy) of New Zealand in 2007 to that in 2009?
Provide a succinct answer. 0.84. What is the ratio of the Clean energy produced (as % of total energy) in Central Europe in 2007 to that in 2010?
Provide a short and direct response. 0.94. What is the ratio of the Clean energy produced (as % of total energy) in Azerbaijan in 2007 to that in 2010?
Your answer should be compact. 0.66. What is the ratio of the Clean energy produced (as % of total energy) in New Zealand in 2007 to that in 2010?
Offer a very short reply. 0.77. What is the ratio of the Clean energy produced (as % of total energy) of Central Europe in 2008 to that in 2009?
Make the answer very short. 0.93. What is the ratio of the Clean energy produced (as % of total energy) in Azerbaijan in 2008 to that in 2009?
Your response must be concise. 0.87. What is the ratio of the Clean energy produced (as % of total energy) of New Zealand in 2008 to that in 2009?
Offer a terse response. 0.89. What is the ratio of the Clean energy produced (as % of total energy) in Central Europe in 2008 to that in 2010?
Your answer should be compact. 1.01. What is the ratio of the Clean energy produced (as % of total energy) in Azerbaijan in 2008 to that in 2010?
Make the answer very short. 0.56. What is the ratio of the Clean energy produced (as % of total energy) in New Zealand in 2008 to that in 2010?
Offer a very short reply. 0.81. What is the ratio of the Clean energy produced (as % of total energy) in Central Europe in 2009 to that in 2010?
Give a very brief answer. 1.09. What is the ratio of the Clean energy produced (as % of total energy) in Azerbaijan in 2009 to that in 2010?
Offer a terse response. 0.65. What is the difference between the highest and the second highest Clean energy produced (as % of total energy) of Central Europe?
Make the answer very short. 0.75. What is the difference between the highest and the second highest Clean energy produced (as % of total energy) of Azerbaijan?
Provide a succinct answer. 0.63. What is the difference between the highest and the second highest Clean energy produced (as % of total energy) in New Zealand?
Offer a very short reply. 2.7. What is the difference between the highest and the lowest Clean energy produced (as % of total energy) of Central Europe?
Keep it short and to the point. 1.58. What is the difference between the highest and the lowest Clean energy produced (as % of total energy) of Azerbaijan?
Give a very brief answer. 1.12. What is the difference between the highest and the lowest Clean energy produced (as % of total energy) of New Zealand?
Your answer should be very brief. 9.82. 